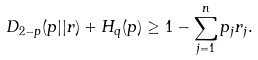Convert formula to latex. <formula><loc_0><loc_0><loc_500><loc_500>D _ { 2 - p } ( p | | r ) + H _ { q } ( p ) \geq 1 - \sum _ { j = 1 } ^ { n } p _ { j } r _ { j } .</formula> 